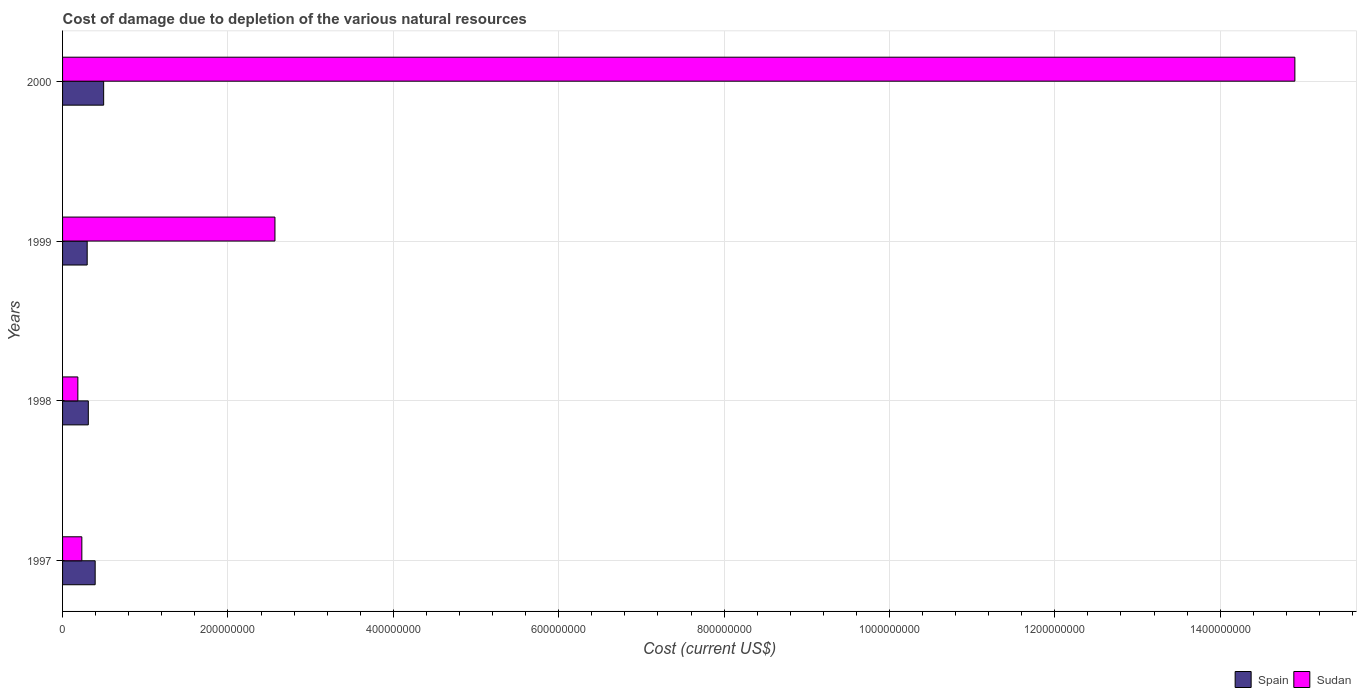How many different coloured bars are there?
Your response must be concise. 2. How many groups of bars are there?
Your answer should be very brief. 4. Are the number of bars per tick equal to the number of legend labels?
Provide a succinct answer. Yes. Are the number of bars on each tick of the Y-axis equal?
Your answer should be compact. Yes. How many bars are there on the 3rd tick from the bottom?
Keep it short and to the point. 2. In how many cases, is the number of bars for a given year not equal to the number of legend labels?
Your response must be concise. 0. What is the cost of damage caused due to the depletion of various natural resources in Spain in 1999?
Provide a short and direct response. 2.98e+07. Across all years, what is the maximum cost of damage caused due to the depletion of various natural resources in Spain?
Keep it short and to the point. 4.97e+07. Across all years, what is the minimum cost of damage caused due to the depletion of various natural resources in Sudan?
Give a very brief answer. 1.85e+07. In which year was the cost of damage caused due to the depletion of various natural resources in Spain minimum?
Your answer should be very brief. 1999. What is the total cost of damage caused due to the depletion of various natural resources in Sudan in the graph?
Offer a terse response. 1.79e+09. What is the difference between the cost of damage caused due to the depletion of various natural resources in Sudan in 1999 and that in 2000?
Your answer should be compact. -1.23e+09. What is the difference between the cost of damage caused due to the depletion of various natural resources in Spain in 1998 and the cost of damage caused due to the depletion of various natural resources in Sudan in 1999?
Your answer should be very brief. -2.26e+08. What is the average cost of damage caused due to the depletion of various natural resources in Sudan per year?
Your answer should be very brief. 4.47e+08. In the year 1999, what is the difference between the cost of damage caused due to the depletion of various natural resources in Spain and cost of damage caused due to the depletion of various natural resources in Sudan?
Offer a very short reply. -2.27e+08. What is the ratio of the cost of damage caused due to the depletion of various natural resources in Spain in 1998 to that in 1999?
Ensure brevity in your answer.  1.05. Is the difference between the cost of damage caused due to the depletion of various natural resources in Spain in 1997 and 2000 greater than the difference between the cost of damage caused due to the depletion of various natural resources in Sudan in 1997 and 2000?
Give a very brief answer. Yes. What is the difference between the highest and the second highest cost of damage caused due to the depletion of various natural resources in Spain?
Your answer should be compact. 1.03e+07. What is the difference between the highest and the lowest cost of damage caused due to the depletion of various natural resources in Sudan?
Your response must be concise. 1.47e+09. Is the sum of the cost of damage caused due to the depletion of various natural resources in Spain in 1997 and 2000 greater than the maximum cost of damage caused due to the depletion of various natural resources in Sudan across all years?
Ensure brevity in your answer.  No. What does the 2nd bar from the top in 1999 represents?
Your response must be concise. Spain. What does the 2nd bar from the bottom in 1999 represents?
Your answer should be very brief. Sudan. Are the values on the major ticks of X-axis written in scientific E-notation?
Your answer should be very brief. No. Does the graph contain grids?
Provide a succinct answer. Yes. How many legend labels are there?
Provide a succinct answer. 2. What is the title of the graph?
Ensure brevity in your answer.  Cost of damage due to depletion of the various natural resources. What is the label or title of the X-axis?
Offer a very short reply. Cost (current US$). What is the Cost (current US$) of Spain in 1997?
Make the answer very short. 3.94e+07. What is the Cost (current US$) in Sudan in 1997?
Offer a terse response. 2.33e+07. What is the Cost (current US$) in Spain in 1998?
Your answer should be compact. 3.11e+07. What is the Cost (current US$) of Sudan in 1998?
Keep it short and to the point. 1.85e+07. What is the Cost (current US$) of Spain in 1999?
Your answer should be compact. 2.98e+07. What is the Cost (current US$) of Sudan in 1999?
Provide a succinct answer. 2.57e+08. What is the Cost (current US$) in Spain in 2000?
Make the answer very short. 4.97e+07. What is the Cost (current US$) of Sudan in 2000?
Make the answer very short. 1.49e+09. Across all years, what is the maximum Cost (current US$) in Spain?
Give a very brief answer. 4.97e+07. Across all years, what is the maximum Cost (current US$) in Sudan?
Provide a short and direct response. 1.49e+09. Across all years, what is the minimum Cost (current US$) in Spain?
Make the answer very short. 2.98e+07. Across all years, what is the minimum Cost (current US$) of Sudan?
Provide a short and direct response. 1.85e+07. What is the total Cost (current US$) of Spain in the graph?
Offer a terse response. 1.50e+08. What is the total Cost (current US$) in Sudan in the graph?
Ensure brevity in your answer.  1.79e+09. What is the difference between the Cost (current US$) of Spain in 1997 and that in 1998?
Make the answer very short. 8.28e+06. What is the difference between the Cost (current US$) in Sudan in 1997 and that in 1998?
Your answer should be compact. 4.81e+06. What is the difference between the Cost (current US$) in Spain in 1997 and that in 1999?
Your answer should be compact. 9.64e+06. What is the difference between the Cost (current US$) in Sudan in 1997 and that in 1999?
Keep it short and to the point. -2.34e+08. What is the difference between the Cost (current US$) of Spain in 1997 and that in 2000?
Keep it short and to the point. -1.03e+07. What is the difference between the Cost (current US$) of Sudan in 1997 and that in 2000?
Offer a very short reply. -1.47e+09. What is the difference between the Cost (current US$) in Spain in 1998 and that in 1999?
Your answer should be very brief. 1.36e+06. What is the difference between the Cost (current US$) of Sudan in 1998 and that in 1999?
Give a very brief answer. -2.38e+08. What is the difference between the Cost (current US$) in Spain in 1998 and that in 2000?
Offer a terse response. -1.85e+07. What is the difference between the Cost (current US$) in Sudan in 1998 and that in 2000?
Your answer should be very brief. -1.47e+09. What is the difference between the Cost (current US$) in Spain in 1999 and that in 2000?
Offer a very short reply. -1.99e+07. What is the difference between the Cost (current US$) in Sudan in 1999 and that in 2000?
Make the answer very short. -1.23e+09. What is the difference between the Cost (current US$) of Spain in 1997 and the Cost (current US$) of Sudan in 1998?
Your response must be concise. 2.09e+07. What is the difference between the Cost (current US$) of Spain in 1997 and the Cost (current US$) of Sudan in 1999?
Ensure brevity in your answer.  -2.17e+08. What is the difference between the Cost (current US$) in Spain in 1997 and the Cost (current US$) in Sudan in 2000?
Give a very brief answer. -1.45e+09. What is the difference between the Cost (current US$) of Spain in 1998 and the Cost (current US$) of Sudan in 1999?
Offer a terse response. -2.26e+08. What is the difference between the Cost (current US$) of Spain in 1998 and the Cost (current US$) of Sudan in 2000?
Provide a short and direct response. -1.46e+09. What is the difference between the Cost (current US$) in Spain in 1999 and the Cost (current US$) in Sudan in 2000?
Provide a short and direct response. -1.46e+09. What is the average Cost (current US$) in Spain per year?
Your answer should be very brief. 3.75e+07. What is the average Cost (current US$) of Sudan per year?
Your answer should be compact. 4.47e+08. In the year 1997, what is the difference between the Cost (current US$) of Spain and Cost (current US$) of Sudan?
Your response must be concise. 1.61e+07. In the year 1998, what is the difference between the Cost (current US$) in Spain and Cost (current US$) in Sudan?
Provide a succinct answer. 1.27e+07. In the year 1999, what is the difference between the Cost (current US$) of Spain and Cost (current US$) of Sudan?
Offer a terse response. -2.27e+08. In the year 2000, what is the difference between the Cost (current US$) in Spain and Cost (current US$) in Sudan?
Keep it short and to the point. -1.44e+09. What is the ratio of the Cost (current US$) in Spain in 1997 to that in 1998?
Ensure brevity in your answer.  1.27. What is the ratio of the Cost (current US$) of Sudan in 1997 to that in 1998?
Your response must be concise. 1.26. What is the ratio of the Cost (current US$) in Spain in 1997 to that in 1999?
Give a very brief answer. 1.32. What is the ratio of the Cost (current US$) in Sudan in 1997 to that in 1999?
Provide a short and direct response. 0.09. What is the ratio of the Cost (current US$) of Spain in 1997 to that in 2000?
Your response must be concise. 0.79. What is the ratio of the Cost (current US$) of Sudan in 1997 to that in 2000?
Keep it short and to the point. 0.02. What is the ratio of the Cost (current US$) in Spain in 1998 to that in 1999?
Offer a very short reply. 1.05. What is the ratio of the Cost (current US$) in Sudan in 1998 to that in 1999?
Your response must be concise. 0.07. What is the ratio of the Cost (current US$) in Spain in 1998 to that in 2000?
Make the answer very short. 0.63. What is the ratio of the Cost (current US$) of Sudan in 1998 to that in 2000?
Your answer should be compact. 0.01. What is the ratio of the Cost (current US$) of Spain in 1999 to that in 2000?
Provide a short and direct response. 0.6. What is the ratio of the Cost (current US$) of Sudan in 1999 to that in 2000?
Offer a very short reply. 0.17. What is the difference between the highest and the second highest Cost (current US$) of Spain?
Ensure brevity in your answer.  1.03e+07. What is the difference between the highest and the second highest Cost (current US$) in Sudan?
Ensure brevity in your answer.  1.23e+09. What is the difference between the highest and the lowest Cost (current US$) in Spain?
Ensure brevity in your answer.  1.99e+07. What is the difference between the highest and the lowest Cost (current US$) of Sudan?
Keep it short and to the point. 1.47e+09. 